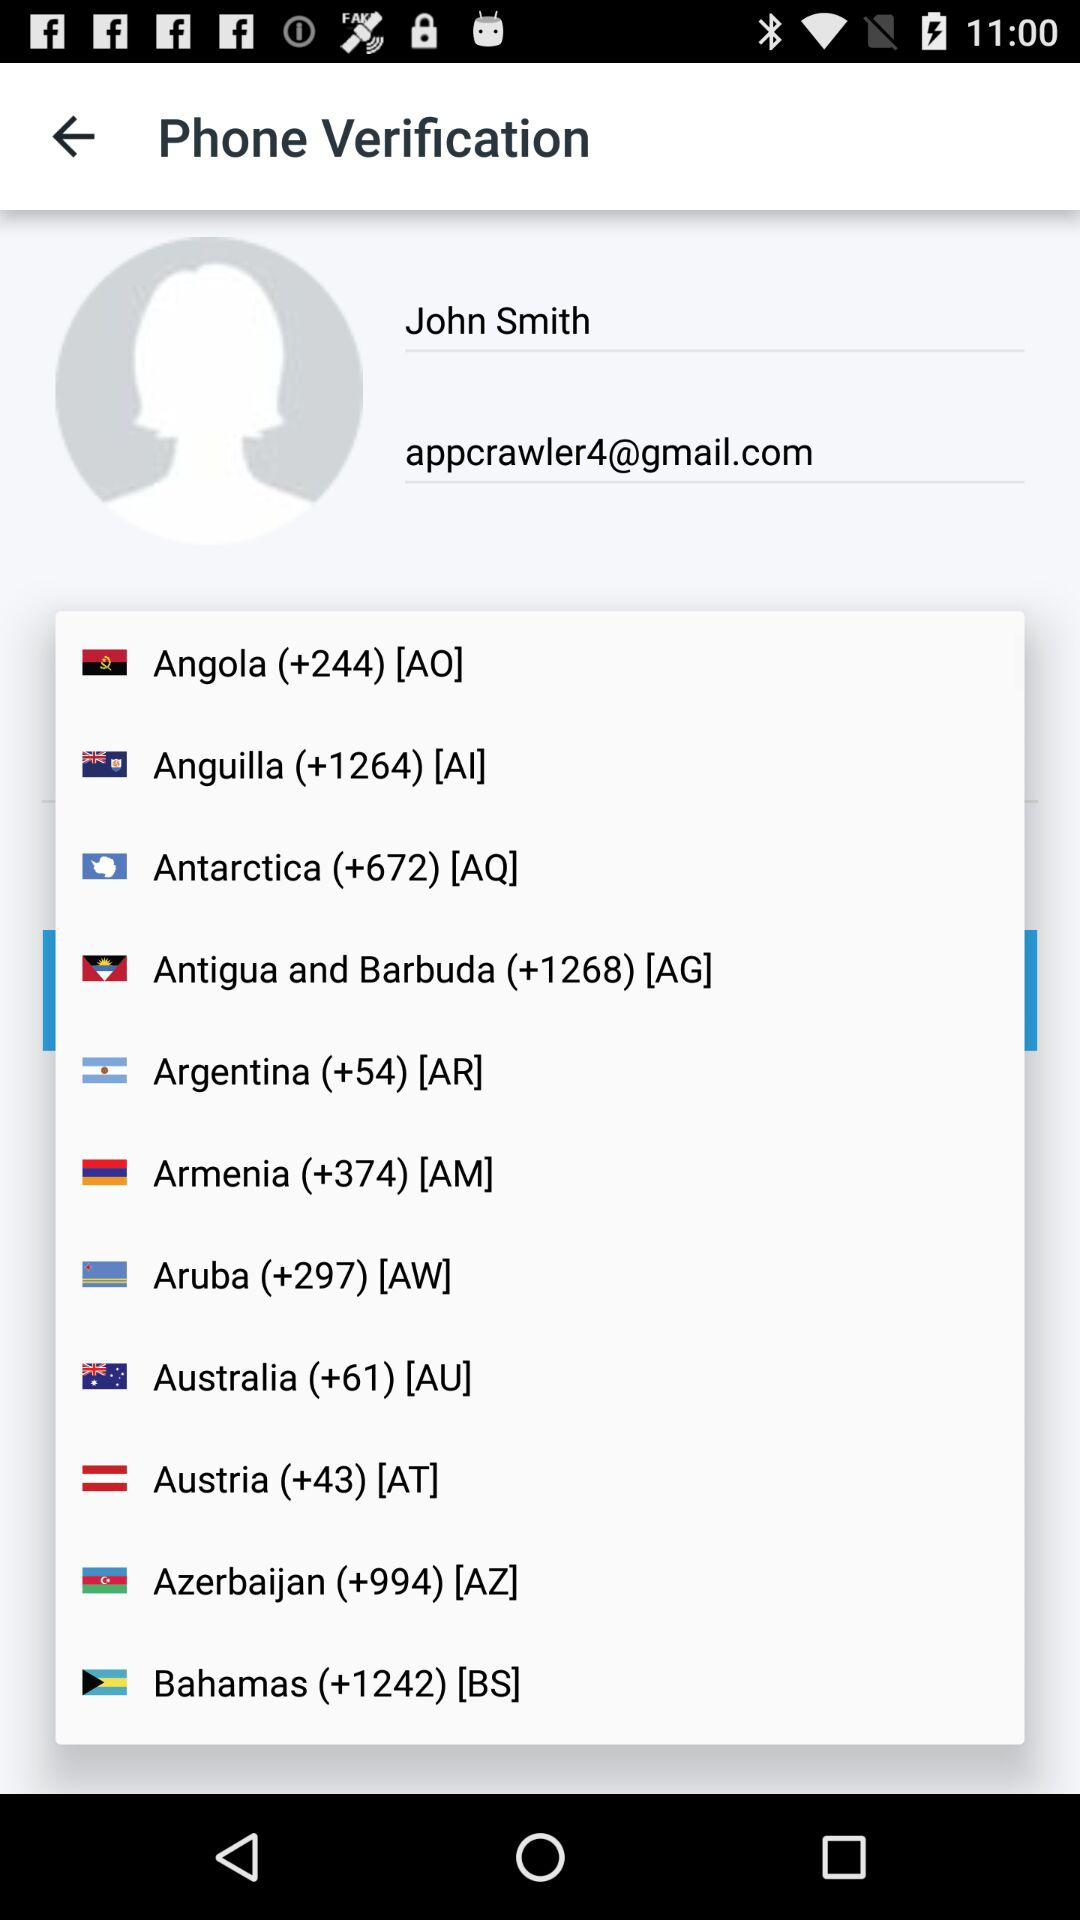What is the country code of Brazil?
When the provided information is insufficient, respond with <no answer>. <no answer> 